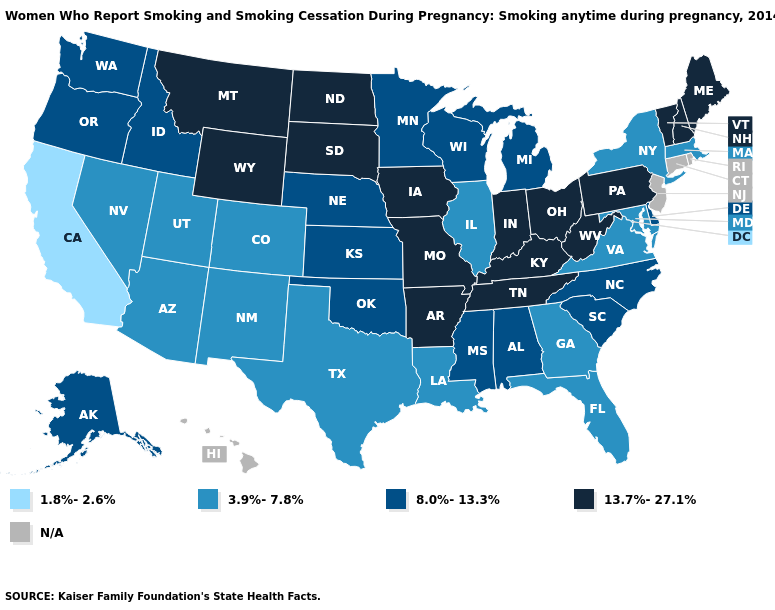Among the states that border Maryland , which have the lowest value?
Concise answer only. Virginia. Name the states that have a value in the range 8.0%-13.3%?
Concise answer only. Alabama, Alaska, Delaware, Idaho, Kansas, Michigan, Minnesota, Mississippi, Nebraska, North Carolina, Oklahoma, Oregon, South Carolina, Washington, Wisconsin. Does New York have the highest value in the Northeast?
Quick response, please. No. Which states hav the highest value in the MidWest?
Concise answer only. Indiana, Iowa, Missouri, North Dakota, Ohio, South Dakota. Does the first symbol in the legend represent the smallest category?
Write a very short answer. Yes. What is the value of West Virginia?
Quick response, please. 13.7%-27.1%. Does Massachusetts have the highest value in the Northeast?
Answer briefly. No. Does Texas have the lowest value in the South?
Write a very short answer. Yes. What is the highest value in states that border Arizona?
Answer briefly. 3.9%-7.8%. What is the highest value in the West ?
Concise answer only. 13.7%-27.1%. Name the states that have a value in the range 1.8%-2.6%?
Write a very short answer. California. What is the lowest value in the Northeast?
Concise answer only. 3.9%-7.8%. Name the states that have a value in the range N/A?
Concise answer only. Connecticut, Hawaii, New Jersey, Rhode Island. Name the states that have a value in the range 13.7%-27.1%?
Concise answer only. Arkansas, Indiana, Iowa, Kentucky, Maine, Missouri, Montana, New Hampshire, North Dakota, Ohio, Pennsylvania, South Dakota, Tennessee, Vermont, West Virginia, Wyoming. Does Tennessee have the highest value in the USA?
Quick response, please. Yes. 